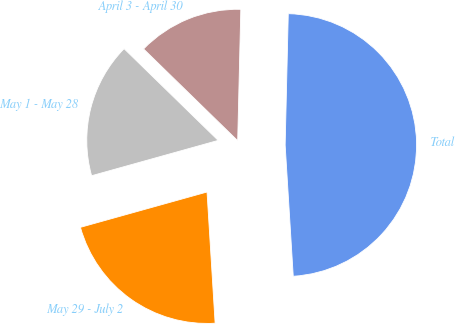Convert chart. <chart><loc_0><loc_0><loc_500><loc_500><pie_chart><fcel>April 3 - April 30<fcel>May 1 - May 28<fcel>May 29 - July 2<fcel>Total<nl><fcel>13.08%<fcel>16.63%<fcel>21.65%<fcel>48.64%<nl></chart> 